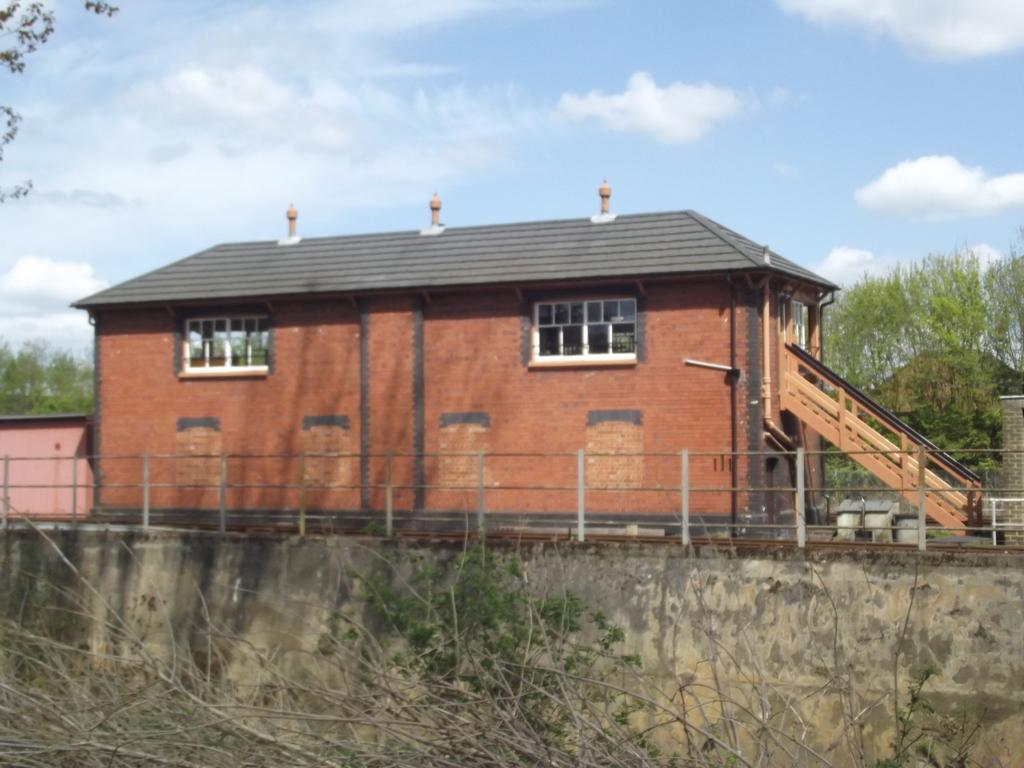What type of structure is visible in the image? There is a building in the image. What feature of the building is mentioned in the facts? The building has a staircase. What is located in front of the building? There is an iron barricade in front of the building. What can be seen in the background of the image? There is a group of trees and a cloudy sky in the background of the image. What type of net is being used to catch food in the image? There is no net or food present in the image. What type of rail is visible in the image? There is no rail mentioned in the facts or visible in the image. 